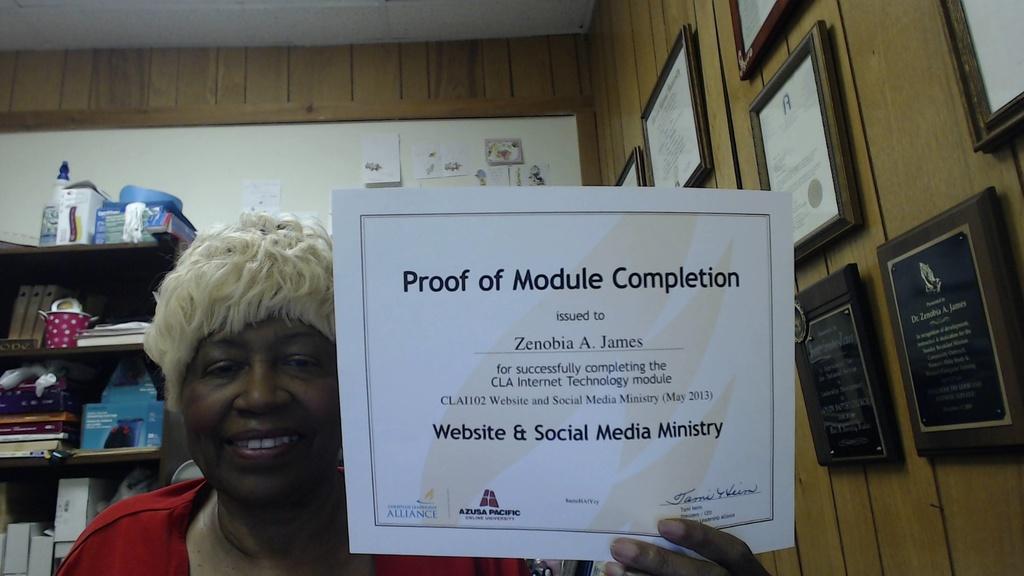Who is the paper issued to?
Provide a succinct answer. Zenobia a. james. What is the paper proof of?
Your response must be concise. Module completion. 